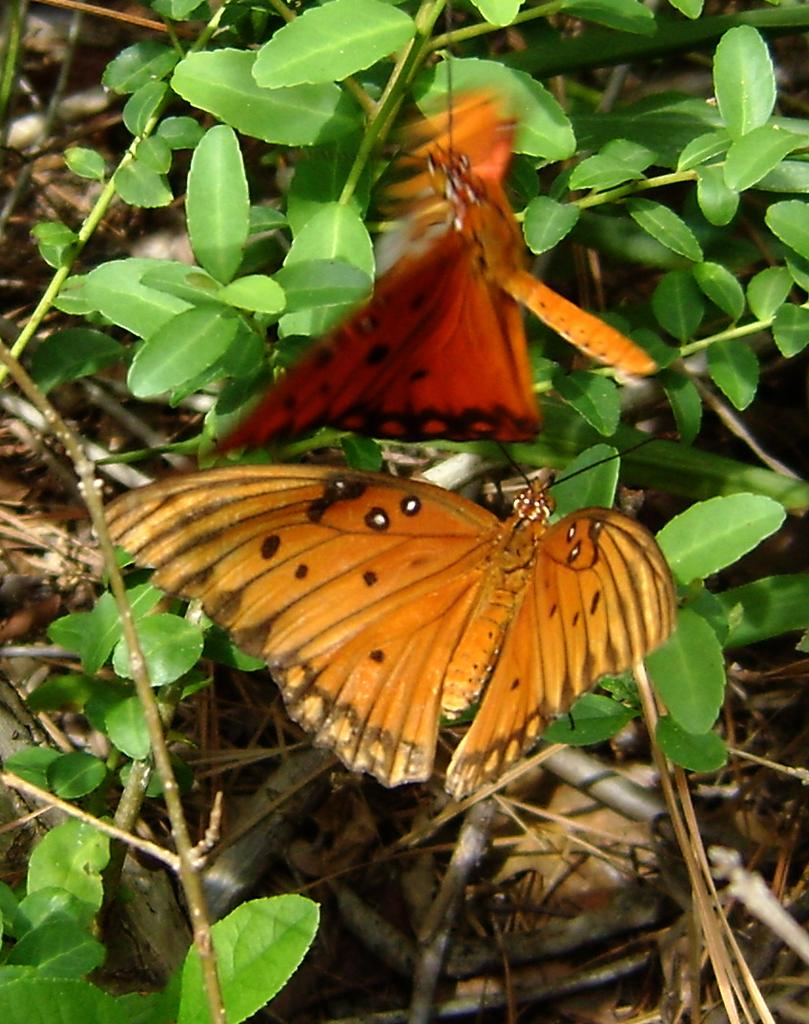What type of animals can be seen in the image? There are butterflies in the image. What other living organisms can be seen in the image? There are plants in the image. What type of soap is being used to clean the butterflies in the image? There is no soap or cleaning activity present in the image; it features butterflies and plants. 